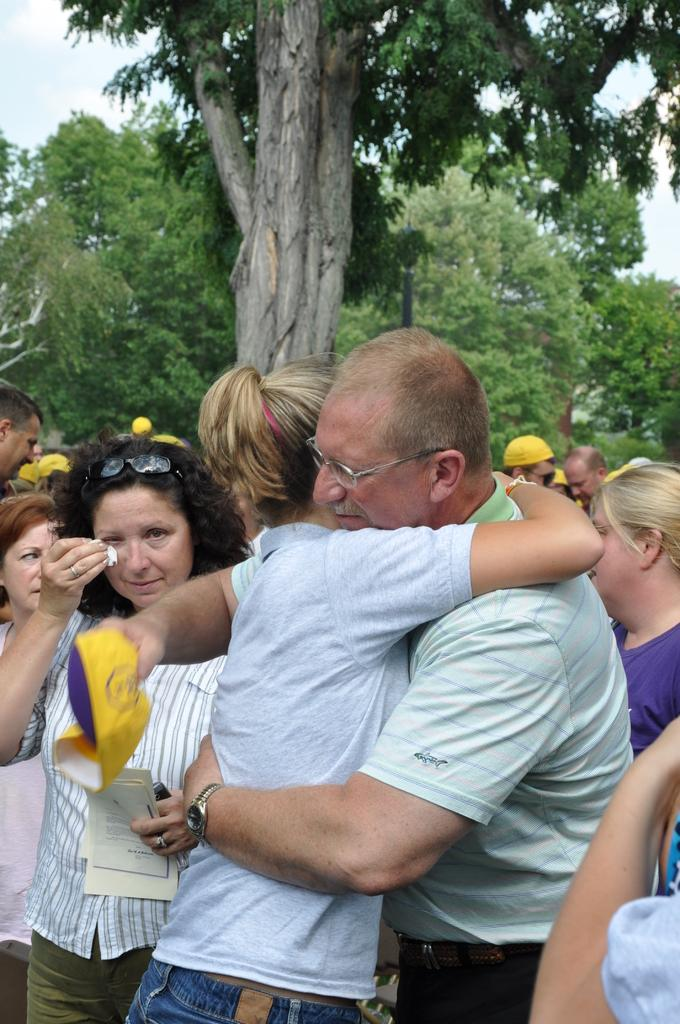Who are the two people in the image? There is a man and a woman in the image. What are the man and woman doing in the image? The man and woman are hugging. Are there any other people in the image besides the man and woman? Yes, there are people standing behind the man and woman. What can be seen in the background of the image? Trees and the sky are visible in the background. What type of apparatus is being used by the man and woman in the image? There is no apparatus present in the image; the man and woman are simply hugging. What kind of trip are the man and woman taking in the image? There is no trip depicted in the image; it shows the man and woman hugging. 